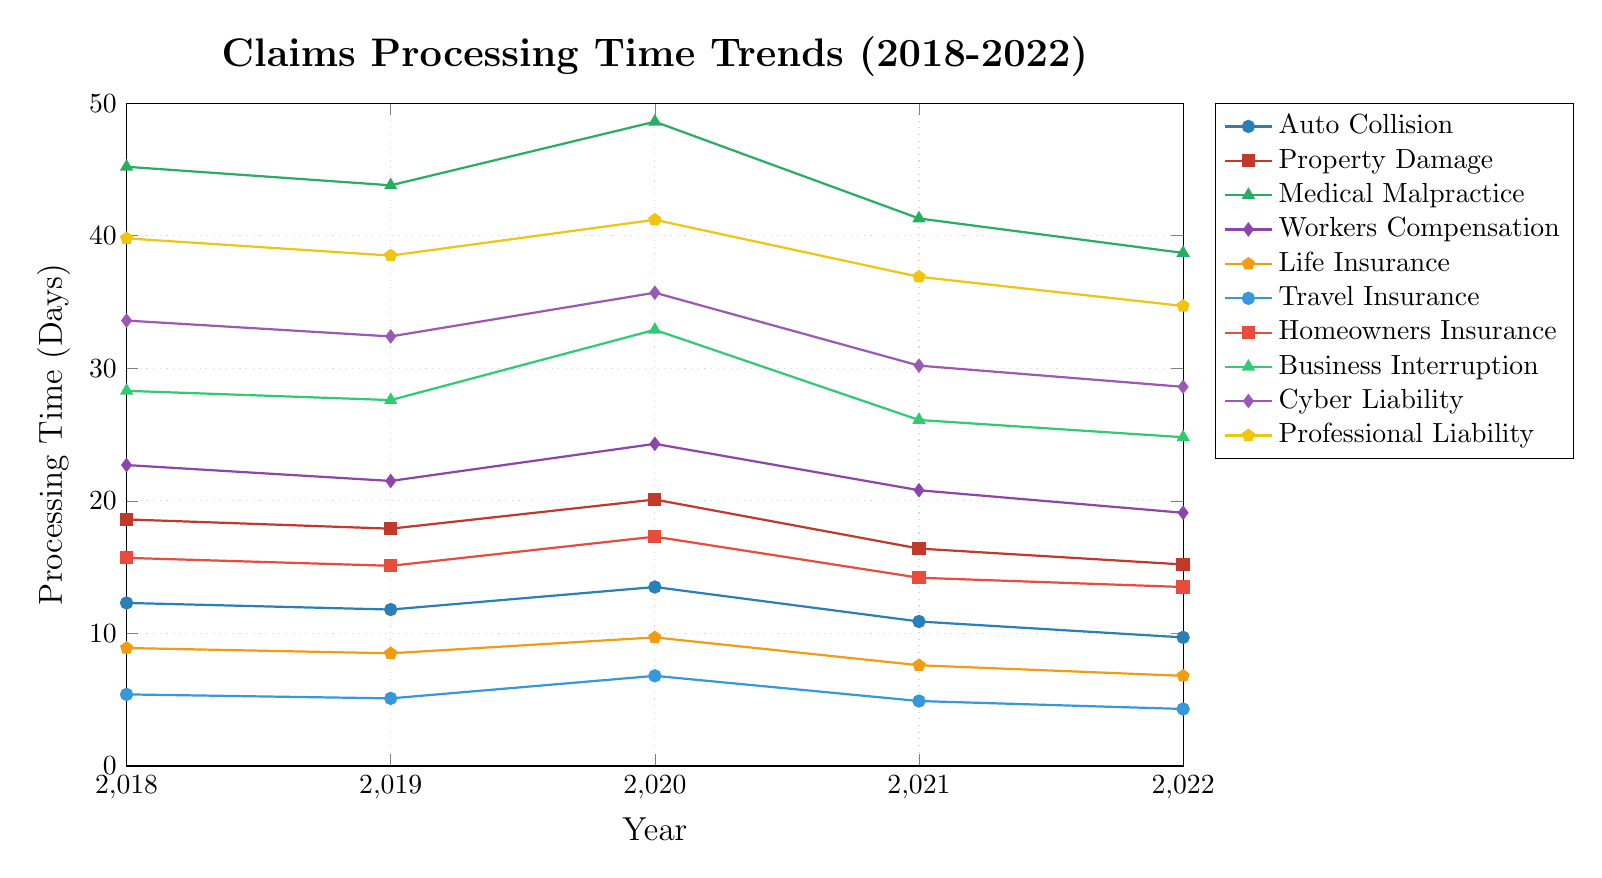Which claim type saw the largest decrease in processing time from 2018 to 2022? To find the largest decrease, subtract the 2022 value from the 2018 value for each claim type and compare the results. For Auto Collision: 12.3 - 9.7 = 2.6, Property Damage: 18.6 - 15.2 = 3.4, Medical Malpractice: 45.2 - 38.7 = 6.5, Workers Compensation: 22.7 - 19.1 = 3.6, Life Insurance: 8.9 - 6.8 = 2.1, Travel Insurance: 5.4 - 4.3 = 1.1, Homeowners Insurance: 15.7 - 13.5 = 2.2, Business Interruption: 28.3 - 24.8 = 3.5, Cyber Liability: 33.6 - 28.6 = 5.0, Professional Liability: 39.8 - 34.7 = 5.1. The largest decrease is for Medical Malpractice (6.5).
Answer: Medical Malpractice In which year did Auto Collision claims processing time peak? Look at the plot for the Auto Collision line (marked with circles) and identify the highest point. The highest point is at 2020 with a processing time of 13.5 days.
Answer: 2020 Which type of claim had the shortest processing time in 2022? Identify the smallest value on the y-axis for 2022 across all claim types. Travel Insurance has the lowest value at 4.3 days.
Answer: Travel Insurance Which claim type had a consistent decrease in processing time every year from 2018 to 2022? Analyze the trend for each claim type's line to see if the processing time decreases every single year from 2018 to 2022. The Life Insurance line consistently decreases from 8.9 (2018) to 8.5 (2019) to 9.7 (2020) to 7.6 (2021) to 6.8 (2022).
Answer: Life Insurance How did the processing time for Business Interruption claims change between 2020 and 2021? Look at the Business Interruption line (marked with triangles) and find the values for 2020 and 2021. Subtract the 2021 value from the 2020 value: 32.9 - 26.1 = 6.8 days.
Answer: Decreased by 6.8 days What is the average claims processing time for Professional Liability from 2018 to 2022? Sum the processing times from 2018 to 2022 and divide by the number of years. (39.8 + 38.5 + 41.2 + 36.9 + 34.7) / 5 = 38.22 days.
Answer: 38.22 days Which claim type showed an increase in processing time in 2020 compared to the previous year? Compare the 2019 and 2020 values for all claim types. The claim types that increased are Auto Collision (11.8 to 13.5), Property Damage (17.9 to 20.1), Medical Malpractice (43.8 to 48.6), Workers Compensation (21.5 to 24.3), Travel Insurance (5.1 to 6.8), Homeowners Insurance (15.1 to 17.3), Business Interruption (27.6 to 32.9), Cyber Liability (32.4 to 35.7), Professional Liability (38.5 to 41.2).
Answer: Multiple Compare the processing time trends between Cyber Liability and Professional Liability from 2018 to 2022. Cyber Liability and Professional Liability both start high with 33.6 and 39.8 days respectively in 2018. Both decline over the years, with minor fluctuations, ending at 28.6 for Cyber Liability and 34.7 for Professional Liability in 2022. Both lines show a general downward trend.
Answer: Both trend downward 